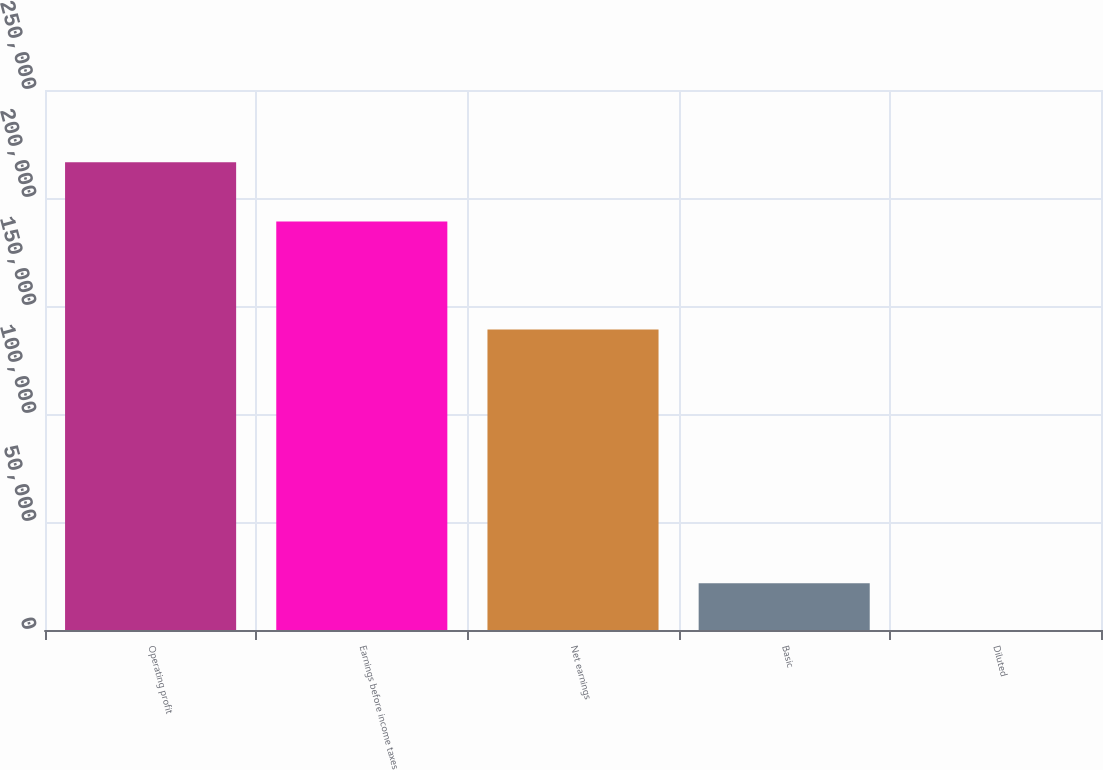Convert chart. <chart><loc_0><loc_0><loc_500><loc_500><bar_chart><fcel>Operating profit<fcel>Earnings before income taxes<fcel>Net earnings<fcel>Basic<fcel>Diluted<nl><fcel>216579<fcel>189144<fcel>139130<fcel>21658.8<fcel>1.06<nl></chart> 